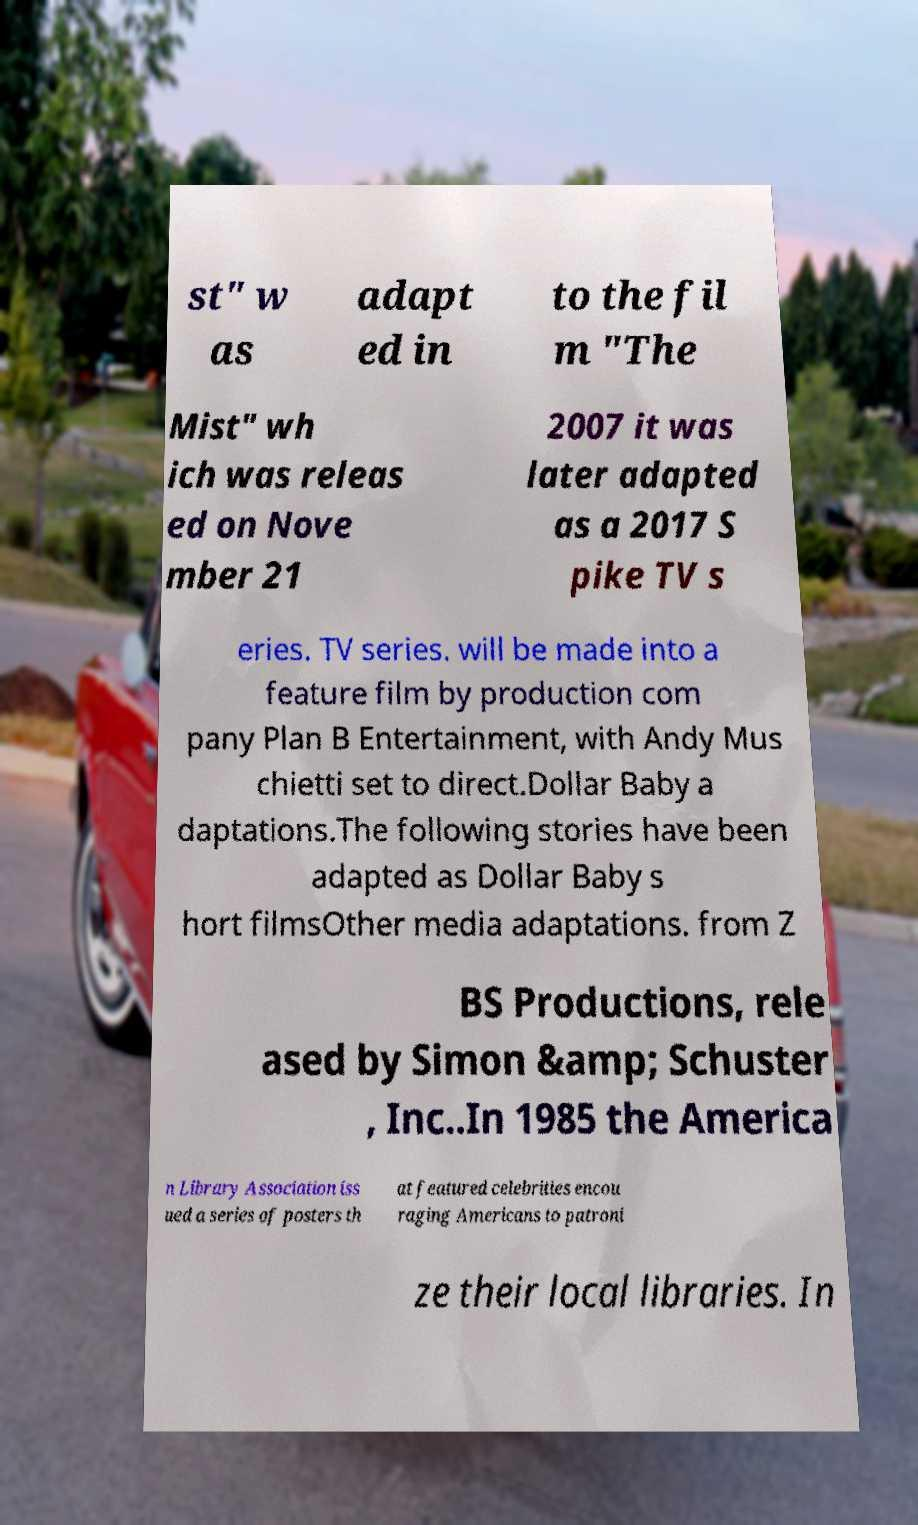Can you read and provide the text displayed in the image?This photo seems to have some interesting text. Can you extract and type it out for me? st" w as adapt ed in to the fil m "The Mist" wh ich was releas ed on Nove mber 21 2007 it was later adapted as a 2017 S pike TV s eries. TV series. will be made into a feature film by production com pany Plan B Entertainment, with Andy Mus chietti set to direct.Dollar Baby a daptations.The following stories have been adapted as Dollar Baby s hort filmsOther media adaptations. from Z BS Productions, rele ased by Simon &amp; Schuster , Inc..In 1985 the America n Library Association iss ued a series of posters th at featured celebrities encou raging Americans to patroni ze their local libraries. In 